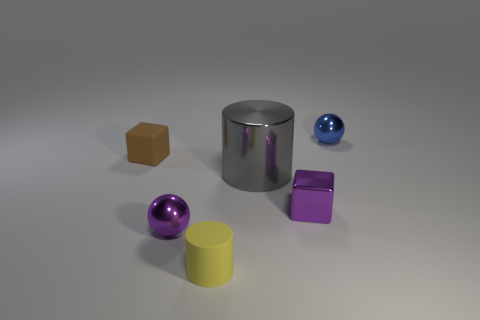There is a shiny object that is the same color as the small metallic block; what size is it?
Your answer should be compact. Small. How many gray things are big cylinders or small cylinders?
Your response must be concise. 1. Is there a object of the same color as the tiny cylinder?
Give a very brief answer. No. What is the size of the other blue object that is made of the same material as the big object?
Ensure brevity in your answer.  Small. What number of spheres are small purple objects or blue metal things?
Keep it short and to the point. 2. Are there more red metal cylinders than yellow rubber cylinders?
Your answer should be very brief. No. What number of yellow rubber cylinders have the same size as the brown matte block?
Your answer should be very brief. 1. What shape is the tiny metallic thing that is the same color as the small shiny cube?
Your response must be concise. Sphere. What number of objects are either cubes that are behind the big gray metallic cylinder or blocks?
Your answer should be very brief. 2. Is the number of tiny blue shiny objects less than the number of tiny cubes?
Your answer should be very brief. Yes. 